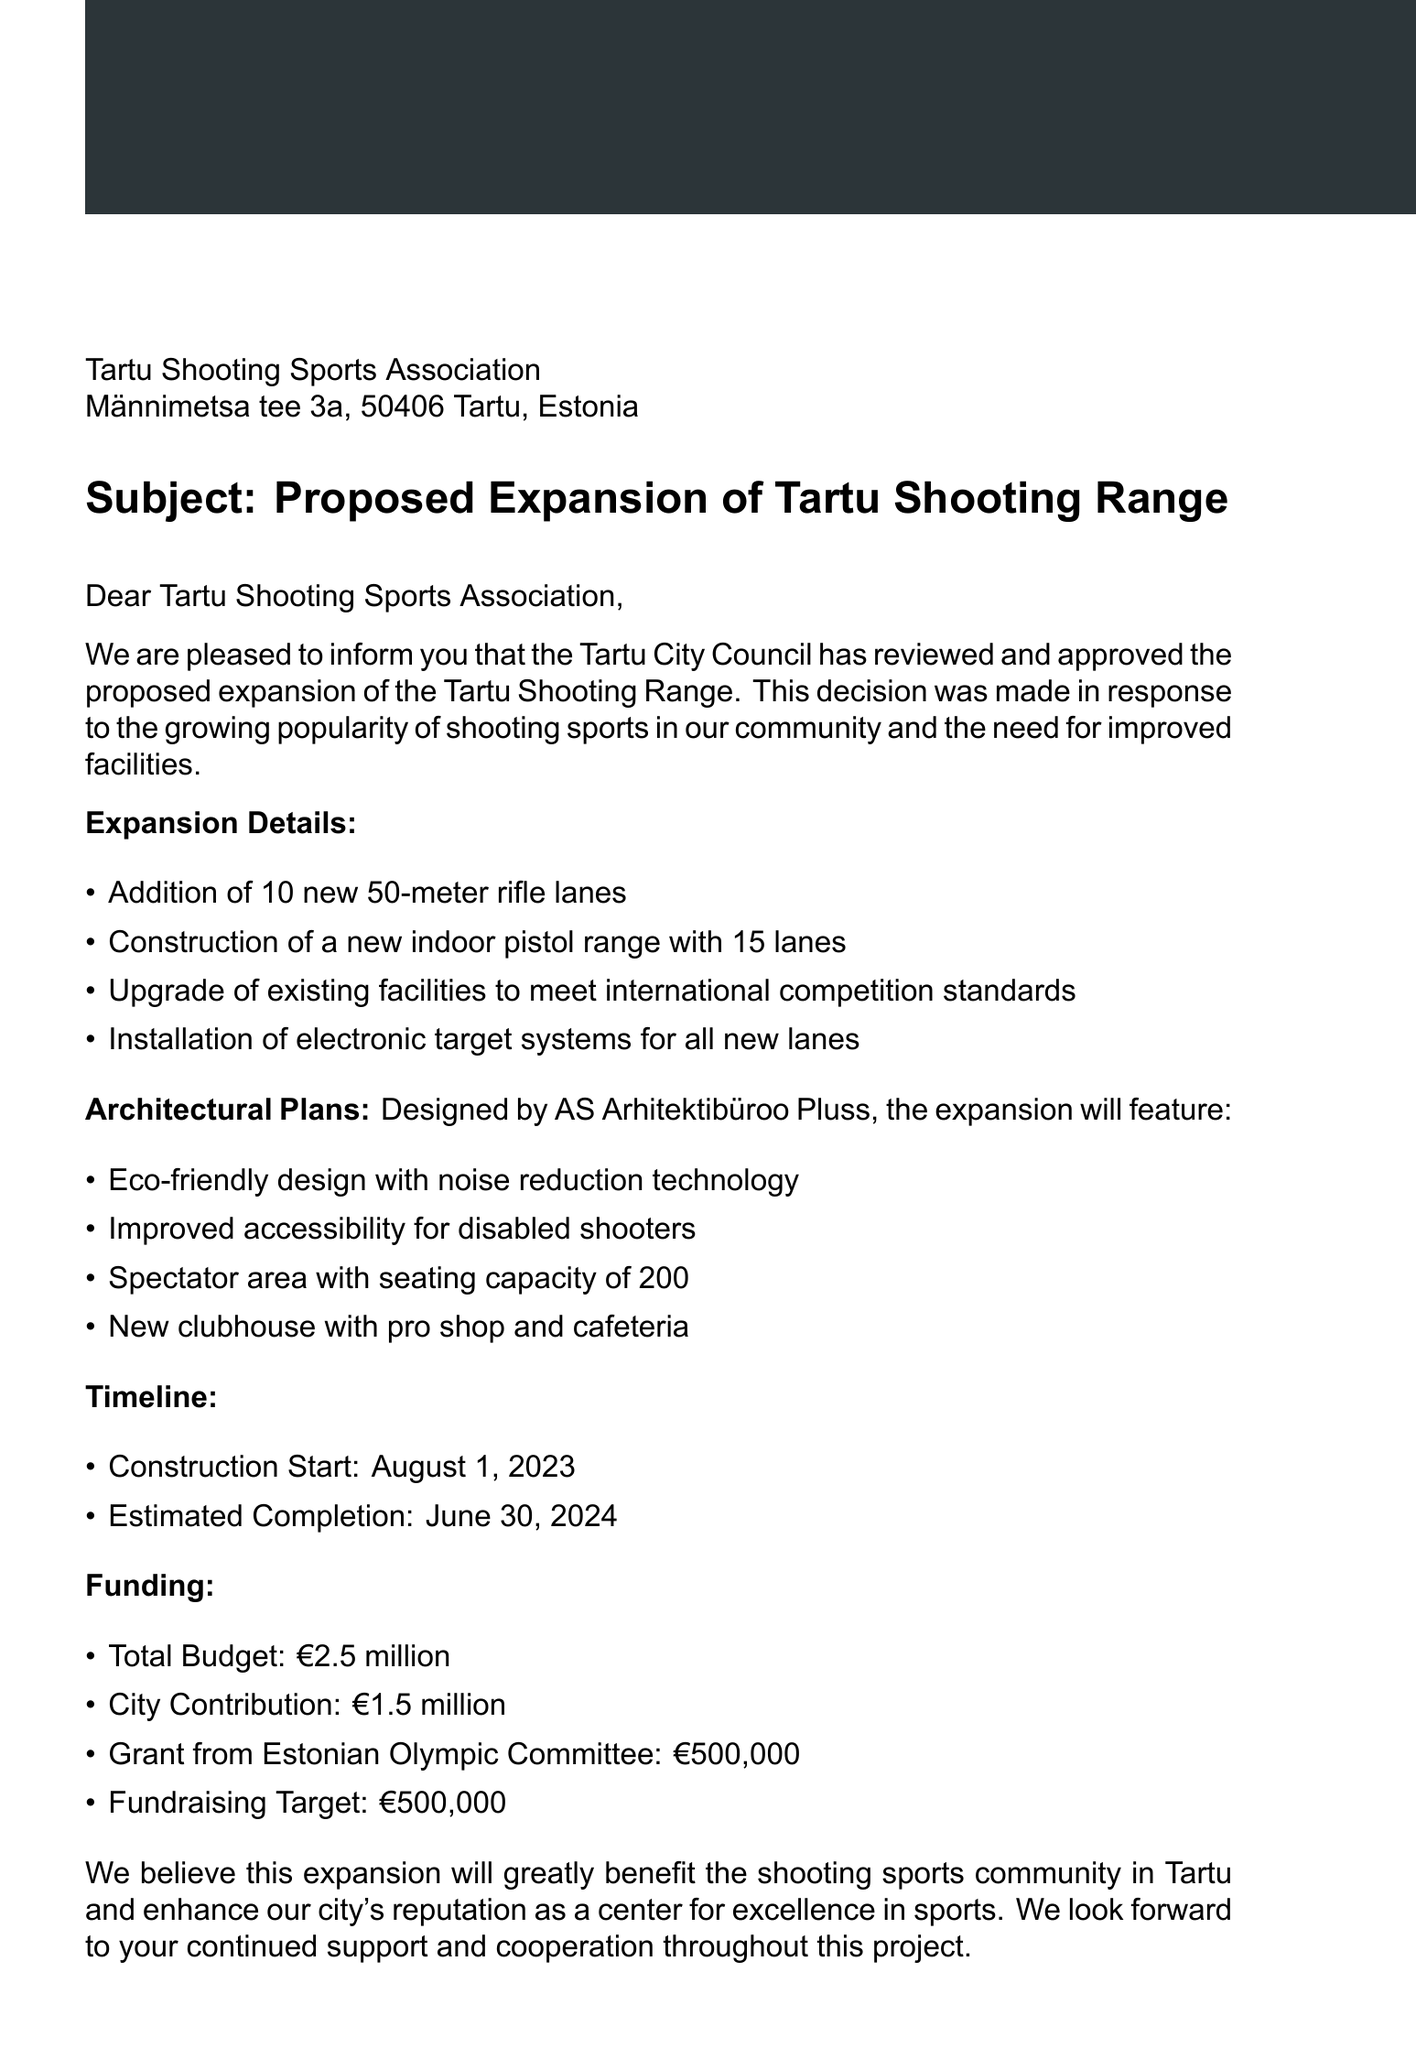What is the sender of the letter? The sender of the letter is specified at the top of the document and identifies who authored the communication.
Answer: Tartu City Council What is the date of the letter? The date is provided in the letterhead and indicates when the letter was written.
Answer: May 15, 2023 How many new rifle lanes are being added? The number of new rifle lanes is mentioned in the expansion details section of the letter.
Answer: 10 new 50-meter rifle lanes Who designed the architectural plans? The designer's name is mentioned in the architectural plans section, indicating who created the design.
Answer: AS Arhitektibüroo Pluss What is the total budget for the expansion? This information can be retrieved from the funding section, which outlines the complete financial requirements for the project.
Answer: €2.5 million What is the estimated completion date for the construction? The estimated completion date is highlighted in the timeline section, detailing when the project is expected to be finished.
Answer: June 30, 2024 What is the seating capacity of the spectator area? The spectator area details are provided under the architectural plans, specifying how many spectators it can accommodate.
Answer: 200 What is the main reason for the expansion of the Tartu Shooting Range? The introduction section provides insight into why the expansion was deemed necessary, focusing on community needs.
Answer: Growing popularity of shooting sports What type of new facility is being constructed? The expansion details mention a specific new facility that will be added to enhance the shooting range offerings.
Answer: New indoor pistol range with 15 lanes 